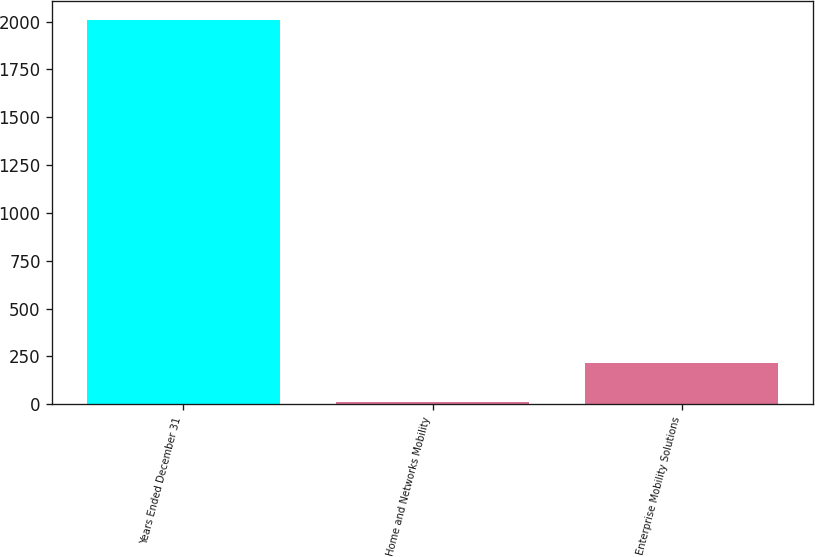<chart> <loc_0><loc_0><loc_500><loc_500><bar_chart><fcel>Years Ended December 31<fcel>Home and Networks Mobility<fcel>Enterprise Mobility Solutions<nl><fcel>2007<fcel>14<fcel>213.3<nl></chart> 